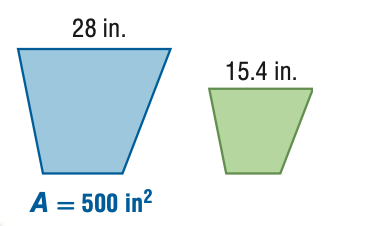Question: For the pair of similar figures, find the area of the green figure.
Choices:
A. 151.25
B. 275.00
C. 909.09
D. 1652.89
Answer with the letter. Answer: A 